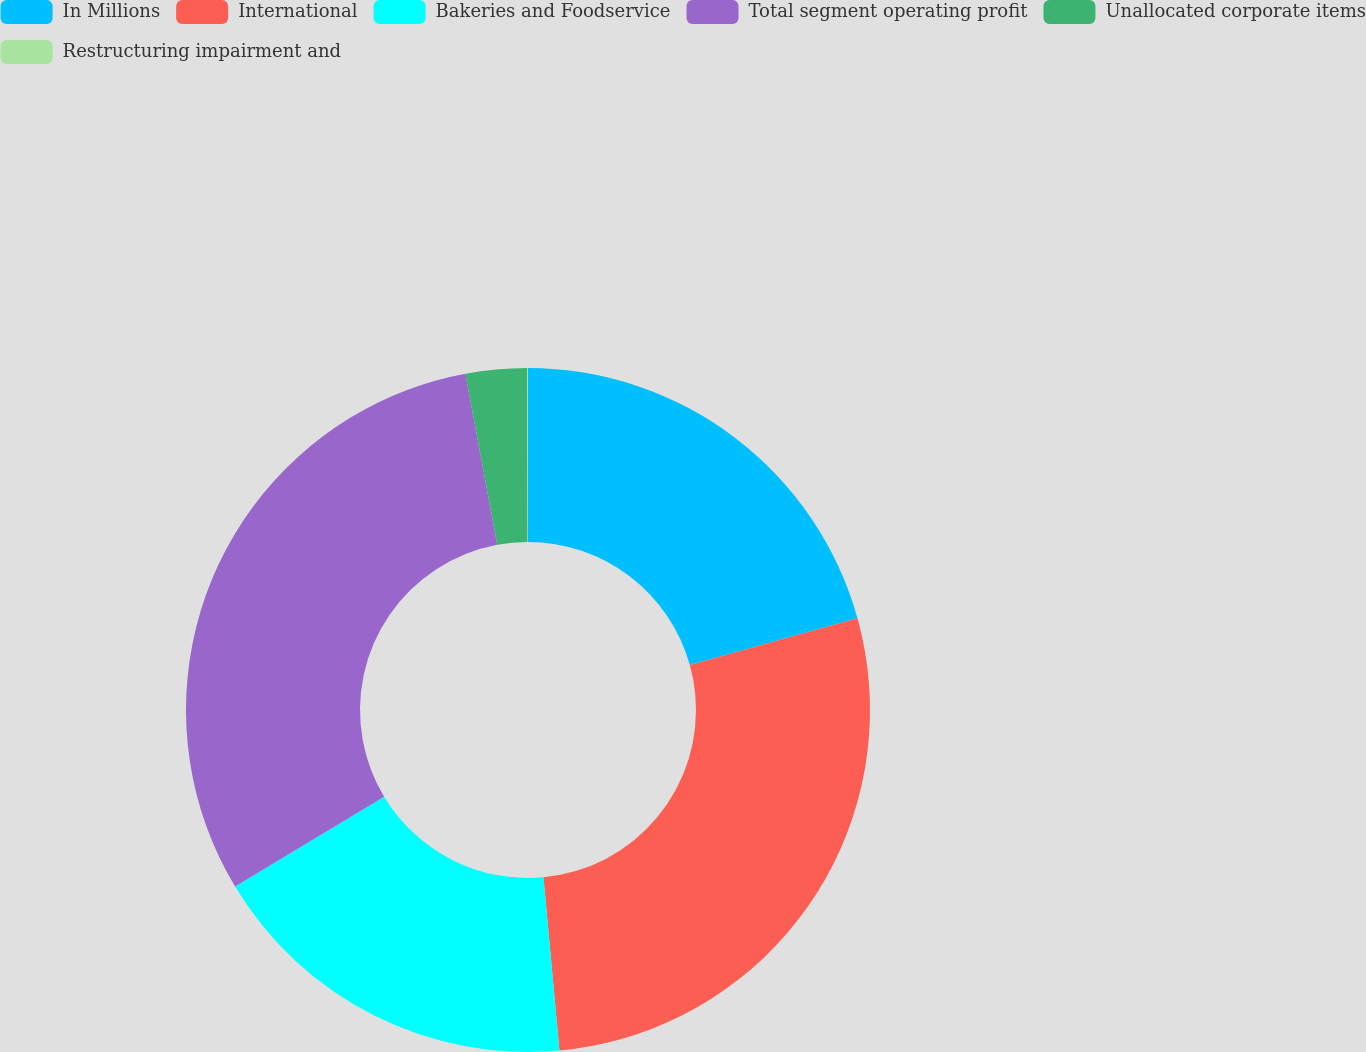Convert chart. <chart><loc_0><loc_0><loc_500><loc_500><pie_chart><fcel>In Millions<fcel>International<fcel>Bakeries and Foodservice<fcel>Total segment operating profit<fcel>Unallocated corporate items<fcel>Restructuring impairment and<nl><fcel>20.68%<fcel>27.85%<fcel>17.83%<fcel>30.7%<fcel>2.89%<fcel>0.04%<nl></chart> 